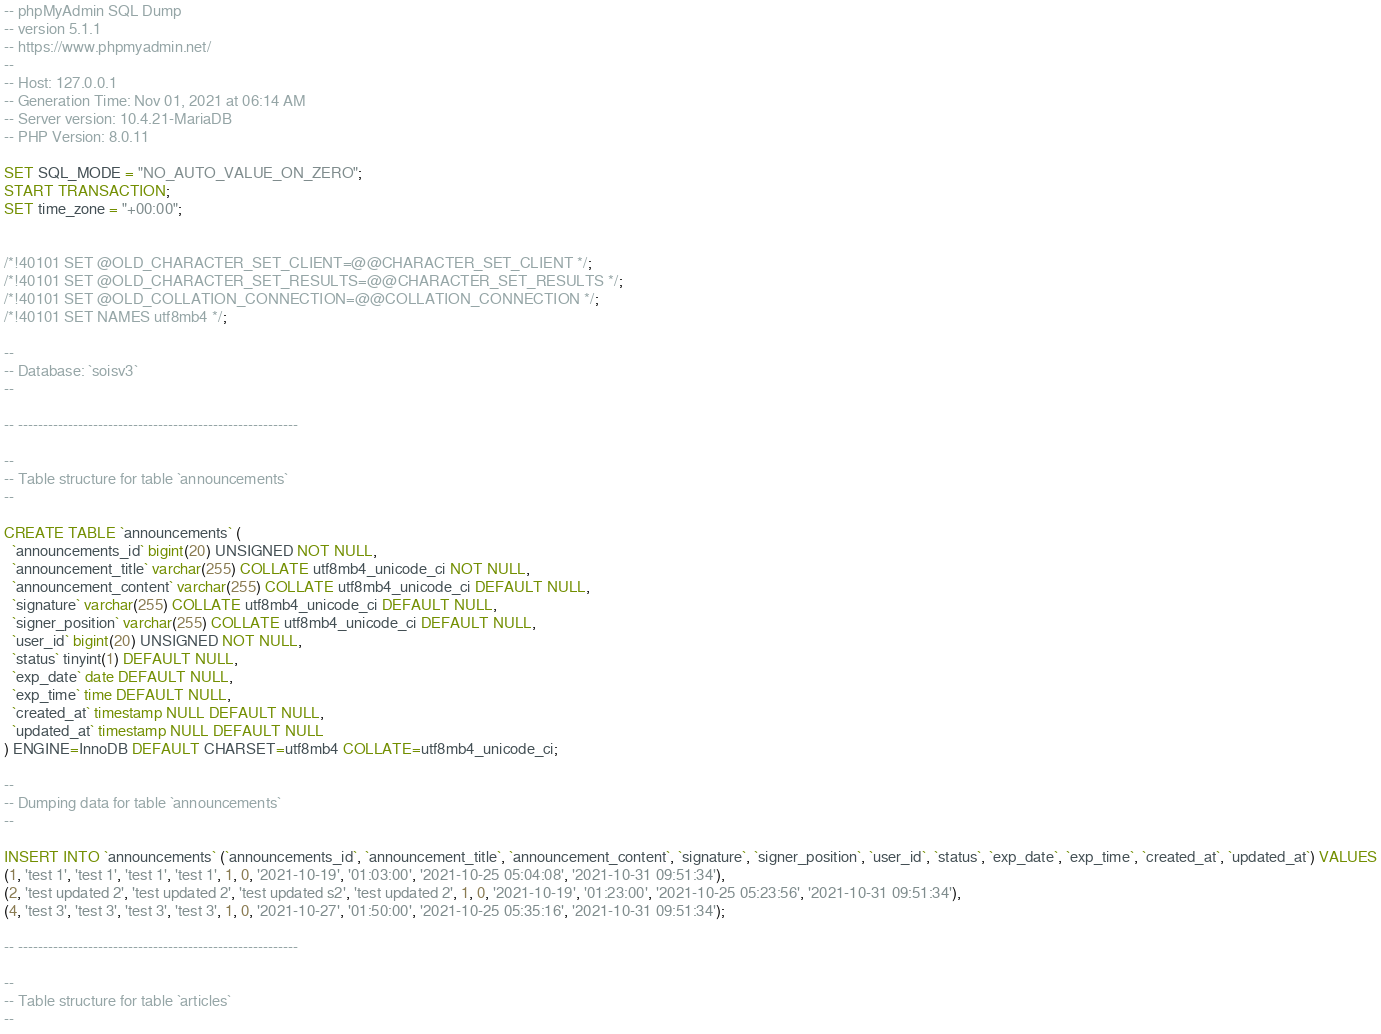<code> <loc_0><loc_0><loc_500><loc_500><_SQL_>-- phpMyAdmin SQL Dump
-- version 5.1.1
-- https://www.phpmyadmin.net/
--
-- Host: 127.0.0.1
-- Generation Time: Nov 01, 2021 at 06:14 AM
-- Server version: 10.4.21-MariaDB
-- PHP Version: 8.0.11

SET SQL_MODE = "NO_AUTO_VALUE_ON_ZERO";
START TRANSACTION;
SET time_zone = "+00:00";


/*!40101 SET @OLD_CHARACTER_SET_CLIENT=@@CHARACTER_SET_CLIENT */;
/*!40101 SET @OLD_CHARACTER_SET_RESULTS=@@CHARACTER_SET_RESULTS */;
/*!40101 SET @OLD_COLLATION_CONNECTION=@@COLLATION_CONNECTION */;
/*!40101 SET NAMES utf8mb4 */;

--
-- Database: `soisv3`
--

-- --------------------------------------------------------

--
-- Table structure for table `announcements`
--

CREATE TABLE `announcements` (
  `announcements_id` bigint(20) UNSIGNED NOT NULL,
  `announcement_title` varchar(255) COLLATE utf8mb4_unicode_ci NOT NULL,
  `announcement_content` varchar(255) COLLATE utf8mb4_unicode_ci DEFAULT NULL,
  `signature` varchar(255) COLLATE utf8mb4_unicode_ci DEFAULT NULL,
  `signer_position` varchar(255) COLLATE utf8mb4_unicode_ci DEFAULT NULL,
  `user_id` bigint(20) UNSIGNED NOT NULL,
  `status` tinyint(1) DEFAULT NULL,
  `exp_date` date DEFAULT NULL,
  `exp_time` time DEFAULT NULL,
  `created_at` timestamp NULL DEFAULT NULL,
  `updated_at` timestamp NULL DEFAULT NULL
) ENGINE=InnoDB DEFAULT CHARSET=utf8mb4 COLLATE=utf8mb4_unicode_ci;

--
-- Dumping data for table `announcements`
--

INSERT INTO `announcements` (`announcements_id`, `announcement_title`, `announcement_content`, `signature`, `signer_position`, `user_id`, `status`, `exp_date`, `exp_time`, `created_at`, `updated_at`) VALUES
(1, 'test 1', 'test 1', 'test 1', 'test 1', 1, 0, '2021-10-19', '01:03:00', '2021-10-25 05:04:08', '2021-10-31 09:51:34'),
(2, 'test updated 2', 'test updated 2', 'test updated s2', 'test updated 2', 1, 0, '2021-10-19', '01:23:00', '2021-10-25 05:23:56', '2021-10-31 09:51:34'),
(4, 'test 3', 'test 3', 'test 3', 'test 3', 1, 0, '2021-10-27', '01:50:00', '2021-10-25 05:35:16', '2021-10-31 09:51:34');

-- --------------------------------------------------------

--
-- Table structure for table `articles`
--
</code> 